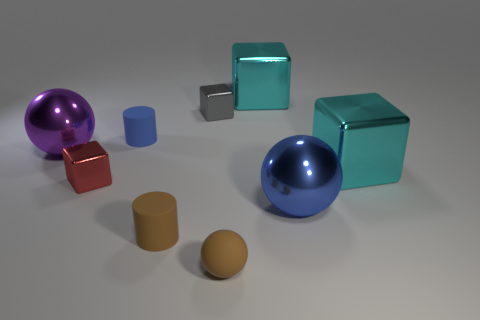Add 1 small gray things. How many objects exist? 10 Subtract all spheres. How many objects are left? 6 Add 8 small brown spheres. How many small brown spheres exist? 9 Subtract 0 yellow cylinders. How many objects are left? 9 Subtract all brown cylinders. Subtract all brown cylinders. How many objects are left? 7 Add 6 purple things. How many purple things are left? 7 